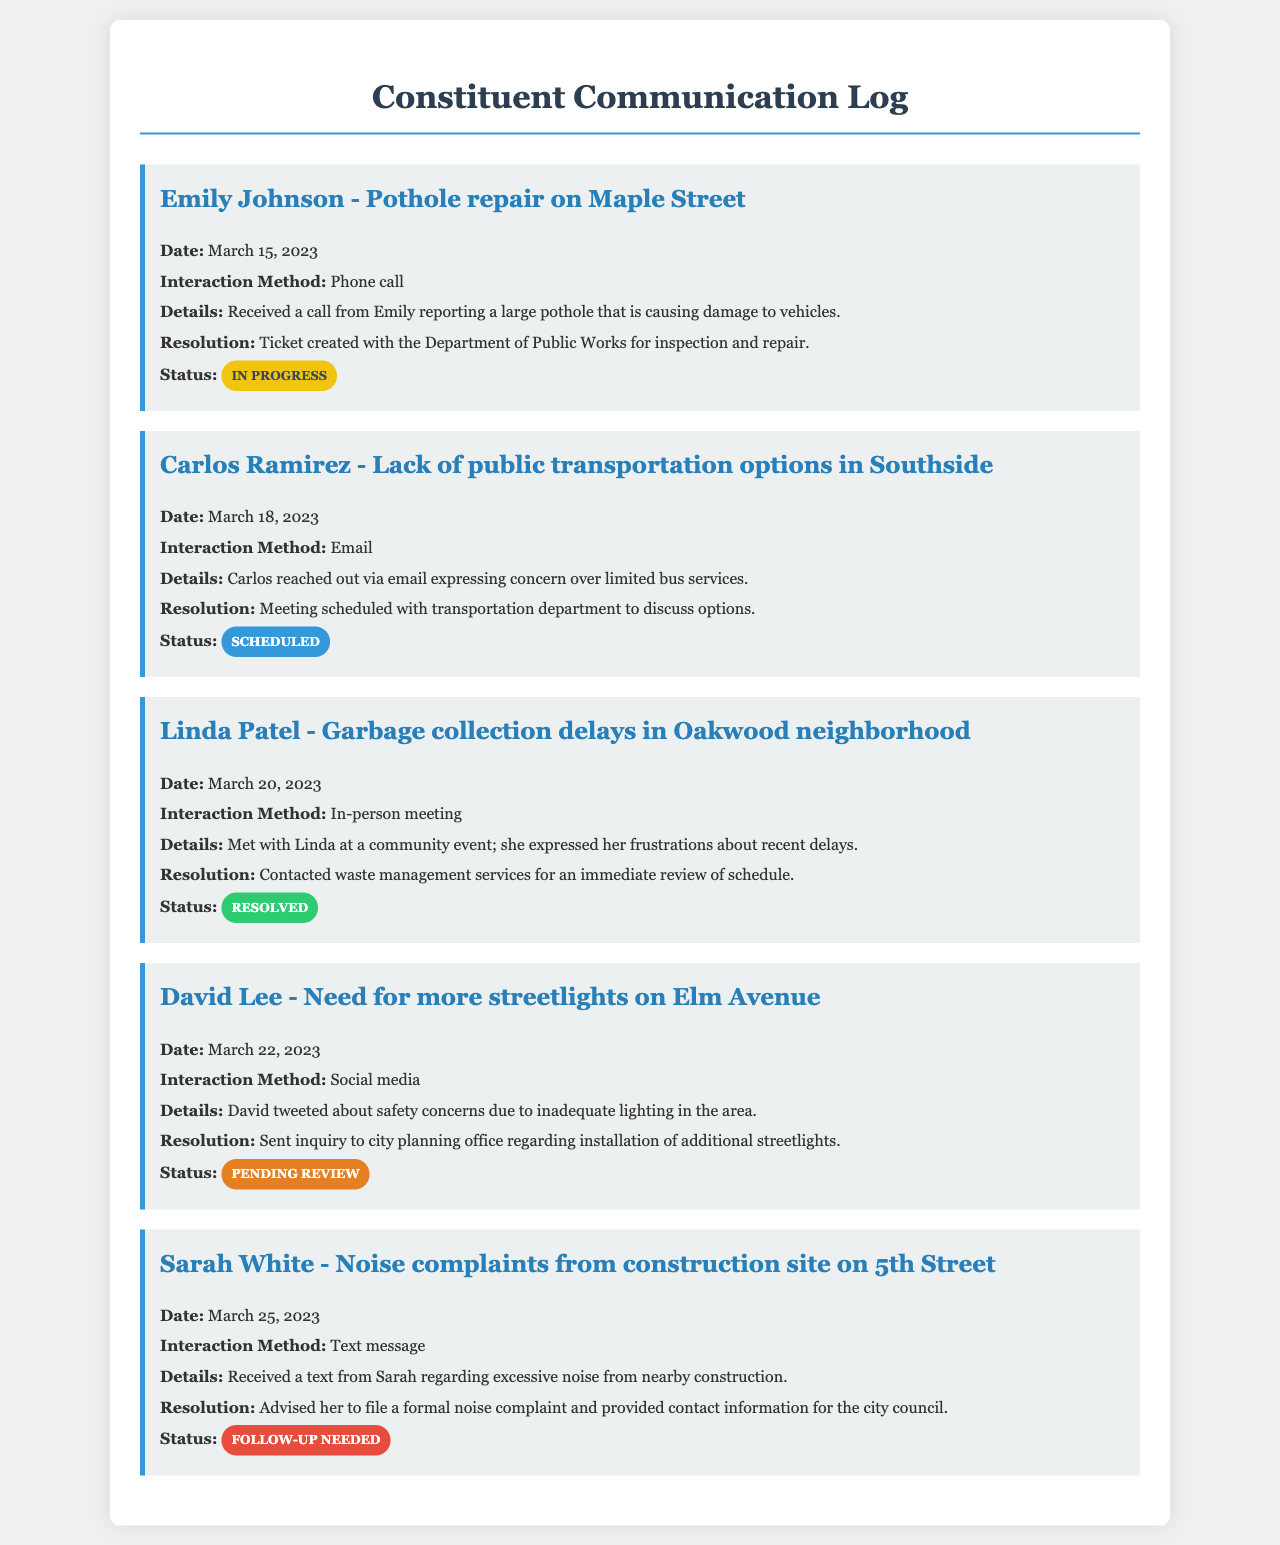What is the date of Emily Johnson's issue? The date of Emily Johnson's issue is mentioned in her log entry.
Answer: March 15, 2023 How did Carlos Ramirez communicate his concern? The method of communication for Carlos Ramirez is specified in his log entry.
Answer: Email What is the resolution for Linda Patel's issue? The resolution for Linda Patel's issue is detailed in her log entry.
Answer: Contacted waste management services for an immediate review of schedule What is the status of David Lee's request? The status of David Lee's request is provided at the end of his log entry.
Answer: Pending review How many people reported issues related to noise? The document mentions only one individual reporting noise-related issues.
Answer: One What was the major concern raised by Emily Johnson? Emily Johnson's major concern is specified in her log entry.
Answer: Pothole repair on Maple Street What is the interaction method mentioned for Sarah White? The log entry provides the interaction method for Sarah White's communication.
Answer: Text message Which community issue had a meeting scheduled? The log entries indicate which issue had a meeting scheduled for further discussion.
Answer: Lack of public transportation options in Southside What is the specific status color for resolved issues? The document specifies how statuses are visually represented, including for resolved issues.
Answer: Green 